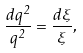Convert formula to latex. <formula><loc_0><loc_0><loc_500><loc_500>\frac { d q ^ { 2 } } { q ^ { 2 } } = \frac { d \xi } { \xi } ,</formula> 